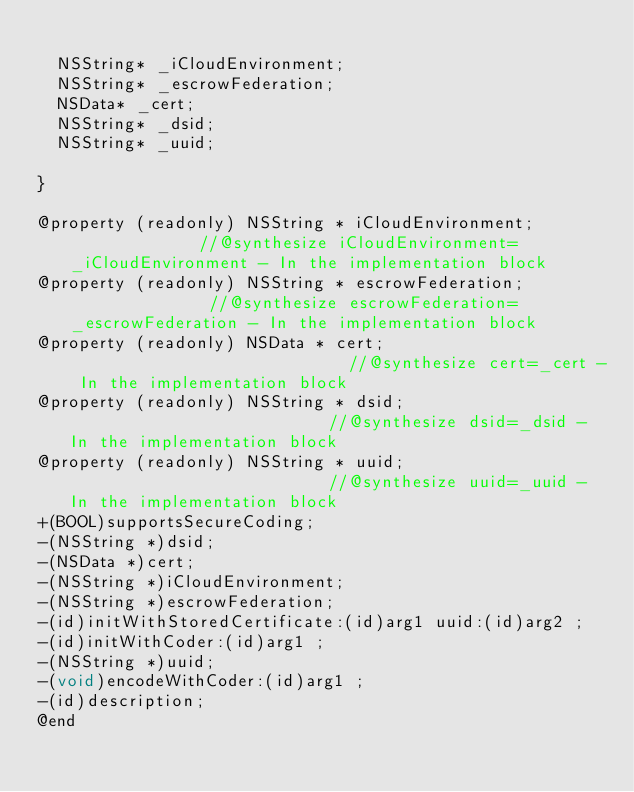Convert code to text. <code><loc_0><loc_0><loc_500><loc_500><_C_>
	NSString* _iCloudEnvironment;
	NSString* _escrowFederation;
	NSData* _cert;
	NSString* _dsid;
	NSString* _uuid;

}

@property (readonly) NSString * iCloudEnvironment;              //@synthesize iCloudEnvironment=_iCloudEnvironment - In the implementation block
@property (readonly) NSString * escrowFederation;               //@synthesize escrowFederation=_escrowFederation - In the implementation block
@property (readonly) NSData * cert;                             //@synthesize cert=_cert - In the implementation block
@property (readonly) NSString * dsid;                           //@synthesize dsid=_dsid - In the implementation block
@property (readonly) NSString * uuid;                           //@synthesize uuid=_uuid - In the implementation block
+(BOOL)supportsSecureCoding;
-(NSString *)dsid;
-(NSData *)cert;
-(NSString *)iCloudEnvironment;
-(NSString *)escrowFederation;
-(id)initWithStoredCertificate:(id)arg1 uuid:(id)arg2 ;
-(id)initWithCoder:(id)arg1 ;
-(NSString *)uuid;
-(void)encodeWithCoder:(id)arg1 ;
-(id)description;
@end

</code> 